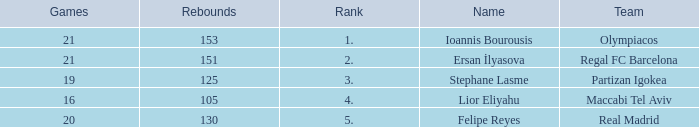What rank is Partizan Igokea that has less than 130 rebounds? 3.0. Could you help me parse every detail presented in this table? {'header': ['Games', 'Rebounds', 'Rank', 'Name', 'Team'], 'rows': [['21', '153', '1.', 'Ioannis Bourousis', 'Olympiacos'], ['21', '151', '2.', 'Ersan İlyasova', 'Regal FC Barcelona'], ['19', '125', '3.', 'Stephane Lasme', 'Partizan Igokea'], ['16', '105', '4.', 'Lior Eliyahu', 'Maccabi Tel Aviv'], ['20', '130', '5.', 'Felipe Reyes', 'Real Madrid']]} 